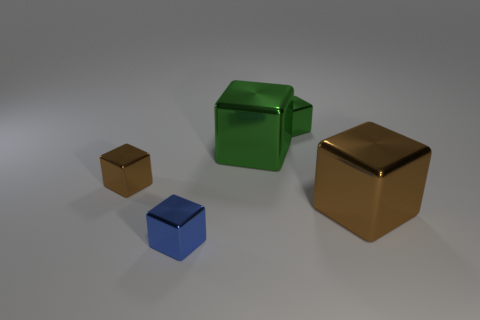There is a shiny thing on the left side of the blue metallic object; is its color the same as the big cube to the right of the big green metal object?
Your response must be concise. Yes. How many other objects are the same size as the blue cube?
Ensure brevity in your answer.  2. What number of metal objects are in front of the small green cube and on the right side of the tiny brown metallic object?
Your answer should be very brief. 3. Are there an equal number of large cubes that are right of the small brown metallic object and tiny things that are to the left of the small blue object?
Give a very brief answer. No. How many big things are brown shiny cubes or metallic blocks?
Your response must be concise. 2. Does the brown object left of the tiny blue object have the same shape as the tiny metallic object that is in front of the large brown metal object?
Make the answer very short. Yes. How many things are things that are in front of the small brown metallic thing or large brown things?
Ensure brevity in your answer.  2. What color is the metallic object behind the large green metal thing?
Your answer should be compact. Green. There is a blue cube that is the same material as the small brown object; what size is it?
Provide a succinct answer. Small. Does the blue object have the same size as the cube that is right of the small green metal thing?
Provide a succinct answer. No. 